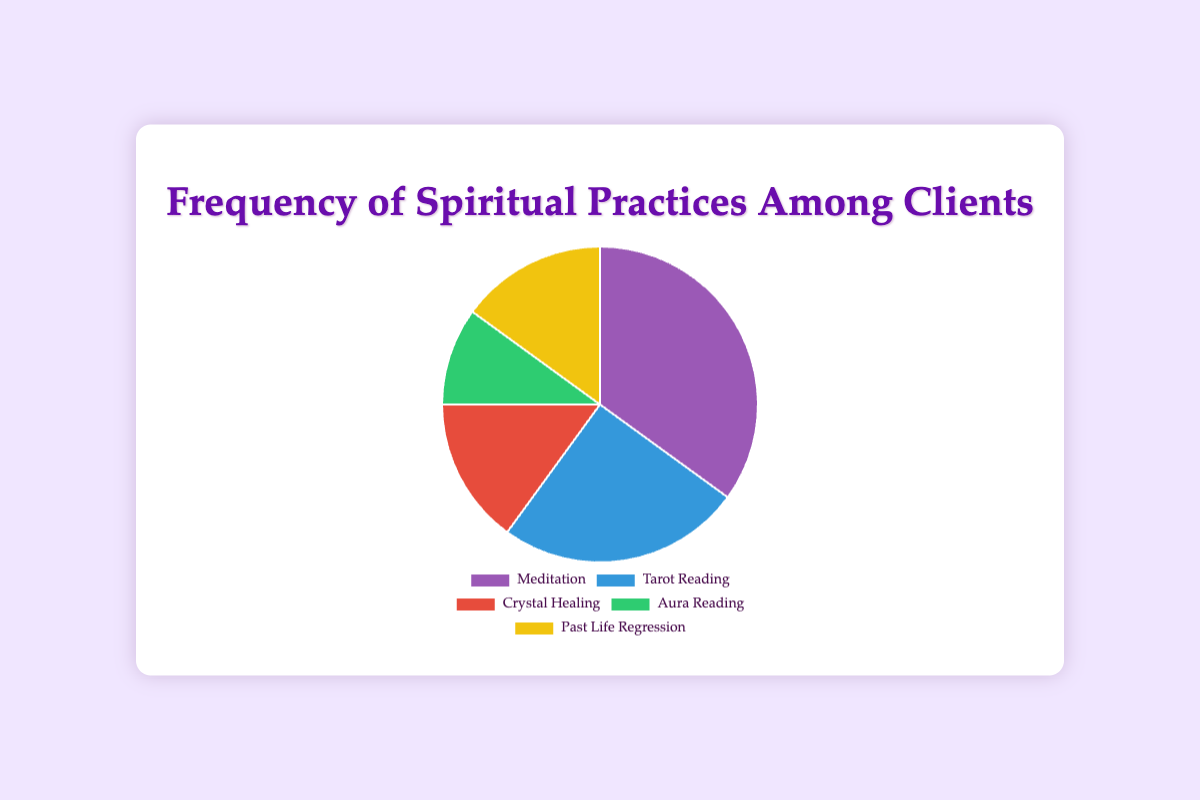Which spiritual practice has the highest frequency among clients? By examining the pie chart, we can see that the largest segment represents Meditation with 35%.
Answer: Meditation Which spiritual practice has the lowest frequency among clients? By observing the pie chart, the smallest segment corresponds to Aura Reading, which is 10%.
Answer: Aura Reading Is the percentage of clients who engage in Meditation greater than the combined percentage of those who engage in Aura Reading and Past Life Regression? Meditation has a frequency of 35%. Adding the frequencies of Aura Reading (10%) and Past Life Regression (15%) equals 25%. Since 35% > 25%, yes, Meditation has a higher percentage.
Answer: Yes How much more frequent is Meditation compared to Crystal Healing? Meditation has a frequency of 35% while Crystal Healing has 15%. The difference is 35% - 15% = 20%.
Answer: 20% If you combine the frequencies of Tarot Reading and Crystal Healing, how does their total compare to the frequency of Meditation? Tarot Reading has a frequency of 25% and Crystal Healing has 15%. Adding them up gives 25% + 15% = 40%. Meditation is 35%, so 40% is greater than 35%.
Answer: Higher Which practice has a frequency equal to two times another practice's frequency? Crystal Healing and Past Life Regression both have 15%, which is twice the frequency of Aura Reading (10%).
Answer: Crystal Healing and Past Life Regression are twice Aura Reading What is the most common color used in the chart, representing the spiritual practices? The color that fills the largest section (representing Meditation) will be seen the most since Meditation is 35% of the chart.
Answer: Purple What's the combined percentage of clients who engage in Meditation and Tarot Reading? Adding the frequency of Meditation (35%) and Tarot Reading (25%), we get 35% + 25% = 60%.
Answer: 60% What proportion of the chart is represented by practices other than Meditation? First, find the frequency of Meditation, which is 35%. Subtracting from the whole, 100% - 35% = 65%.
Answer: 65% Which practices, when combined, represent exactly half of the total clients' frequencies? Tarot Reading (25%) and Crystal Healing (15%) together make 25% + 15% = 40%. Adding Aura Reading (10%) to the mix, 40% + 10% = 50%. These three practices combined make up half the chart.
Answer: Tarot Reading, Crystal Healing, and Aura Reading 